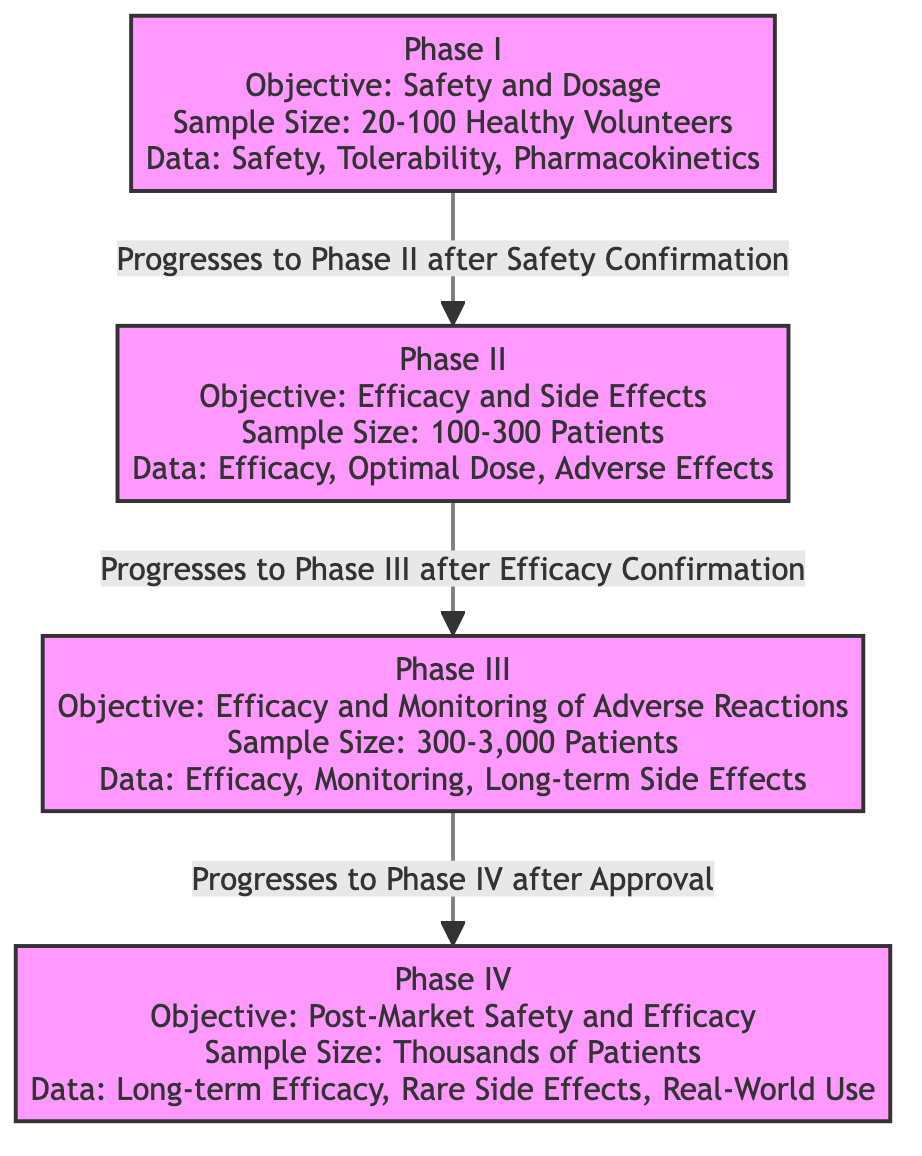What is the objective of Phase II? The diagram indicates that the objective of Phase II is "Efficacy and Side Effects," which can be found in the information box for Phase II.
Answer: Efficacy and Side Effects What is the sample size range for Phase III? By examining the Phase III section of the diagram, it shows a sample size range of "300-3,000 Patients."
Answer: 300-3,000 Patients How many patients are included in the sample size of Phase I? According to the diagram, Phase I includes a sample size of "20-100 Healthy Volunteers." This information is specified in the relevant section on Phase I.
Answer: 20-100 Healthy Volunteers What type of data is collected in Phase IV? The diagram clearly states that the types of data collected in Phase IV are "Long-term Efficacy, Rare Side Effects, Real-World Use." This is depicted in the Phase IV section.
Answer: Long-term Efficacy, Rare Side Effects, Real-World Use Which phase progresses to Phase II after safety confirmation? The flowchart indicates a direct progression from Phase I to Phase II upon confirming safety, as evidenced by the connecting edge labeled "Progresses to Phase II after Safety Confirmation."
Answer: Phase I What is the main objective of Phase III? Looking at the Phase III box, it shows that the main objective is "Efficacy and Monitoring of Adverse Reactions." This information is clearly outlined in the diagram.
Answer: Efficacy and Monitoring of Adverse Reactions How many phases must a drug progress through before reaching Phase IV? From the diagram, we can see that a drug has to go through three phases: Phase I, Phase II, and Phase III, before it can progress to Phase IV. Thus, the answer is derived from the connections shown in the flowchart.
Answer: Three phases What is the relationship between Phase II and Phase III? The diagram illustrates that Phase II progresses to Phase III after confirming efficacy, denoted by the arrow with the label "Progresses to Phase III after Efficacy Confirmation." This describes the direct relationship and progression from one phase to the next.
Answer: Progresses to Phase III after Efficacy Confirmation What is the minimum sample size required for Phase II? The diagram states that the sample size for Phase II is "100-300 Patients," so the minimum sample size is clearly mentioned within this range in the section dedicated to Phase II.
Answer: 100 